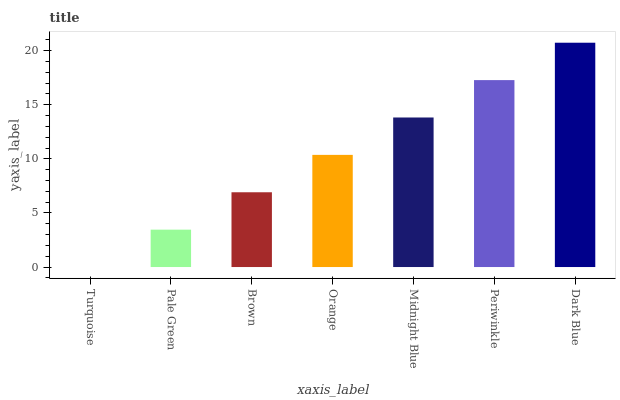Is Turquoise the minimum?
Answer yes or no. Yes. Is Dark Blue the maximum?
Answer yes or no. Yes. Is Pale Green the minimum?
Answer yes or no. No. Is Pale Green the maximum?
Answer yes or no. No. Is Pale Green greater than Turquoise?
Answer yes or no. Yes. Is Turquoise less than Pale Green?
Answer yes or no. Yes. Is Turquoise greater than Pale Green?
Answer yes or no. No. Is Pale Green less than Turquoise?
Answer yes or no. No. Is Orange the high median?
Answer yes or no. Yes. Is Orange the low median?
Answer yes or no. Yes. Is Pale Green the high median?
Answer yes or no. No. Is Turquoise the low median?
Answer yes or no. No. 